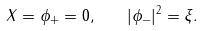Convert formula to latex. <formula><loc_0><loc_0><loc_500><loc_500>X = \phi _ { + } = 0 , \quad | \phi _ { - } | ^ { 2 } = \xi .</formula> 